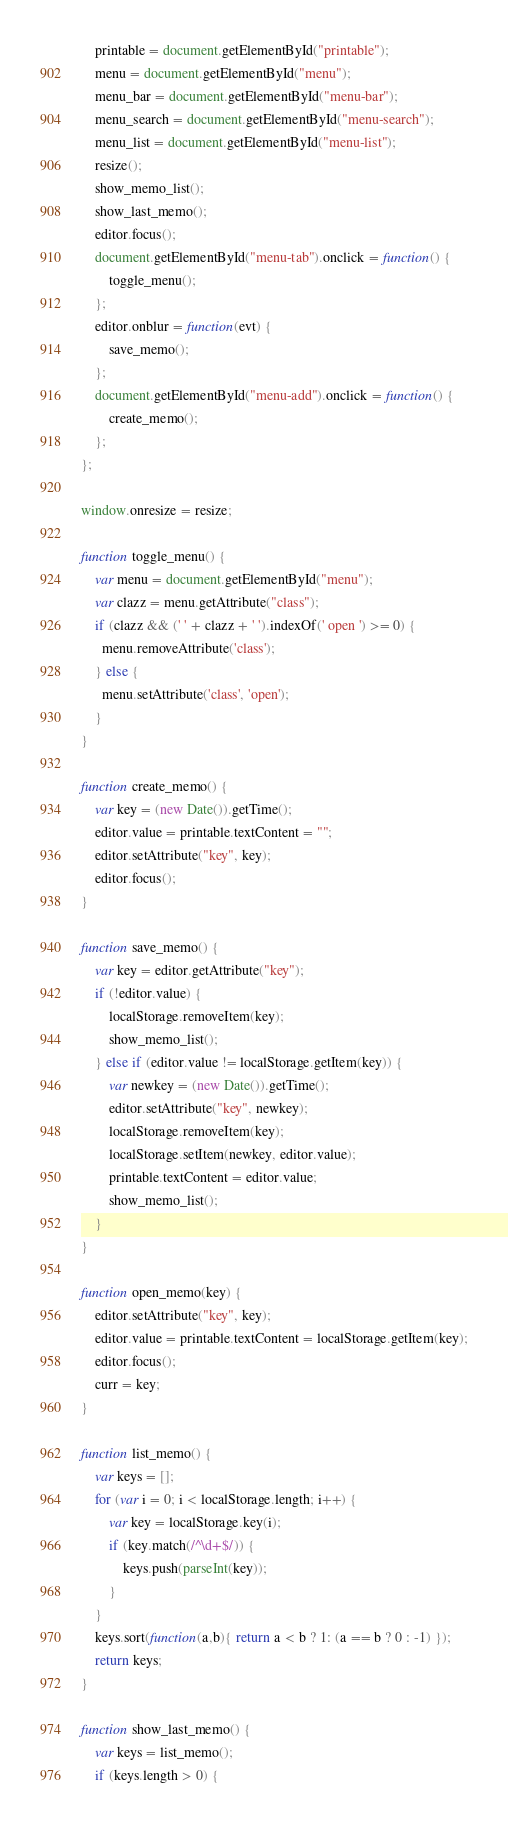<code> <loc_0><loc_0><loc_500><loc_500><_JavaScript_>    printable = document.getElementById("printable");
    menu = document.getElementById("menu");
    menu_bar = document.getElementById("menu-bar");
    menu_search = document.getElementById("menu-search");
    menu_list = document.getElementById("menu-list");
    resize();
    show_memo_list();
    show_last_memo();
    editor.focus();
    document.getElementById("menu-tab").onclick = function() {
        toggle_menu();
    };
    editor.onblur = function(evt) {
        save_memo();
    };
    document.getElementById("menu-add").onclick = function() {
        create_memo();
    };
};

window.onresize = resize;

function toggle_menu() {
    var menu = document.getElementById("menu");
    var clazz = menu.getAttribute("class");
    if (clazz && (' ' + clazz + ' ').indexOf(' open ') >= 0) {
      menu.removeAttribute('class');
    } else {
      menu.setAttribute('class', 'open');
    }
}

function create_memo() {
    var key = (new Date()).getTime();
    editor.value = printable.textContent = "";
    editor.setAttribute("key", key);
    editor.focus();
}

function save_memo() {
    var key = editor.getAttribute("key");
    if (!editor.value) {
        localStorage.removeItem(key);
        show_memo_list();
    } else if (editor.value != localStorage.getItem(key)) {
        var newkey = (new Date()).getTime();
        editor.setAttribute("key", newkey);
        localStorage.removeItem(key);
        localStorage.setItem(newkey, editor.value);
        printable.textContent = editor.value;
        show_memo_list();
    }
}

function open_memo(key) {
    editor.setAttribute("key", key);
    editor.value = printable.textContent = localStorage.getItem(key);
    editor.focus();
    curr = key;
}

function list_memo() {
    var keys = [];
    for (var i = 0; i < localStorage.length; i++) {
        var key = localStorage.key(i);
        if (key.match(/^\d+$/)) {
            keys.push(parseInt(key));
        } 
    }
    keys.sort(function(a,b){ return a < b ? 1: (a == b ? 0 : -1) });
    return keys;
}

function show_last_memo() {
    var keys = list_memo();
    if (keys.length > 0) {</code> 